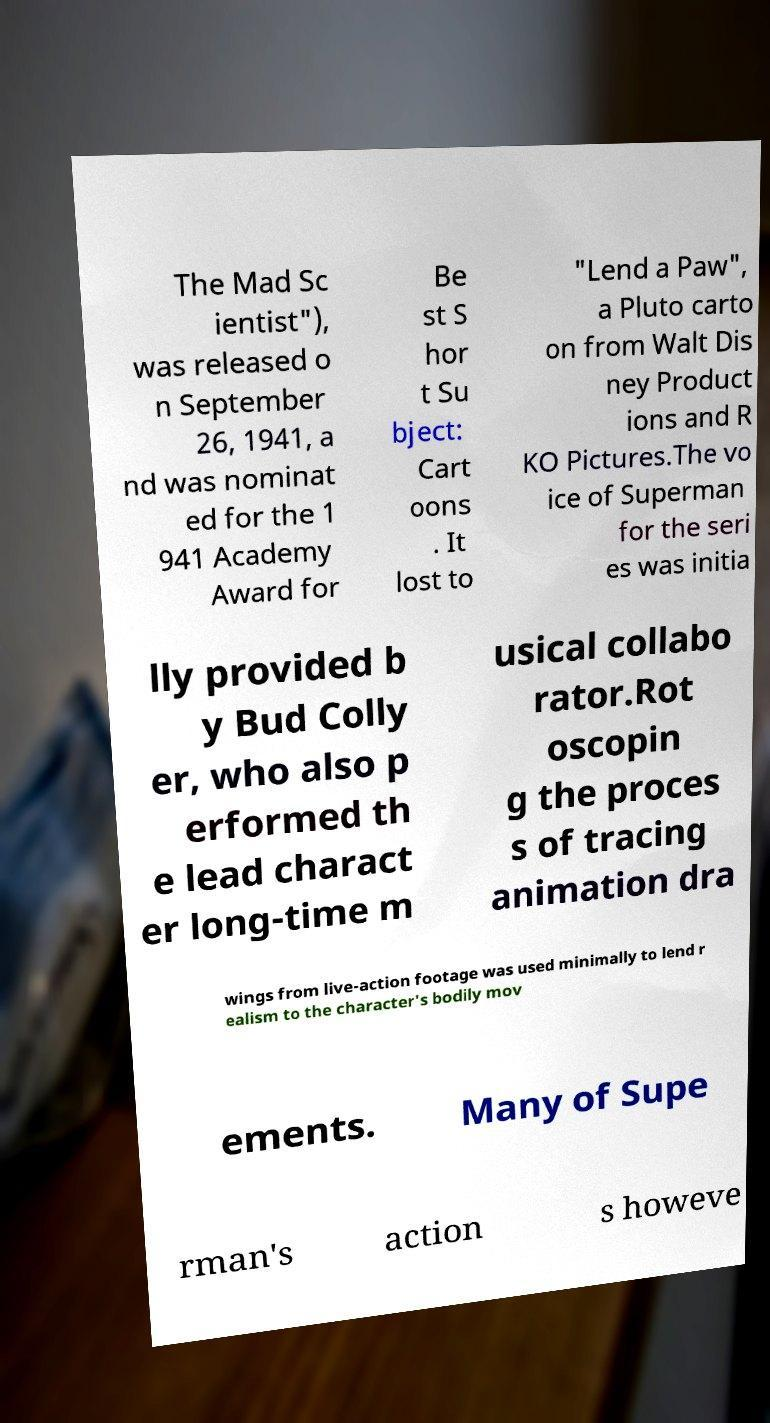What messages or text are displayed in this image? I need them in a readable, typed format. The Mad Sc ientist"), was released o n September 26, 1941, a nd was nominat ed for the 1 941 Academy Award for Be st S hor t Su bject: Cart oons . It lost to "Lend a Paw", a Pluto carto on from Walt Dis ney Product ions and R KO Pictures.The vo ice of Superman for the seri es was initia lly provided b y Bud Colly er, who also p erformed th e lead charact er long-time m usical collabo rator.Rot oscopin g the proces s of tracing animation dra wings from live-action footage was used minimally to lend r ealism to the character's bodily mov ements. Many of Supe rman's action s howeve 